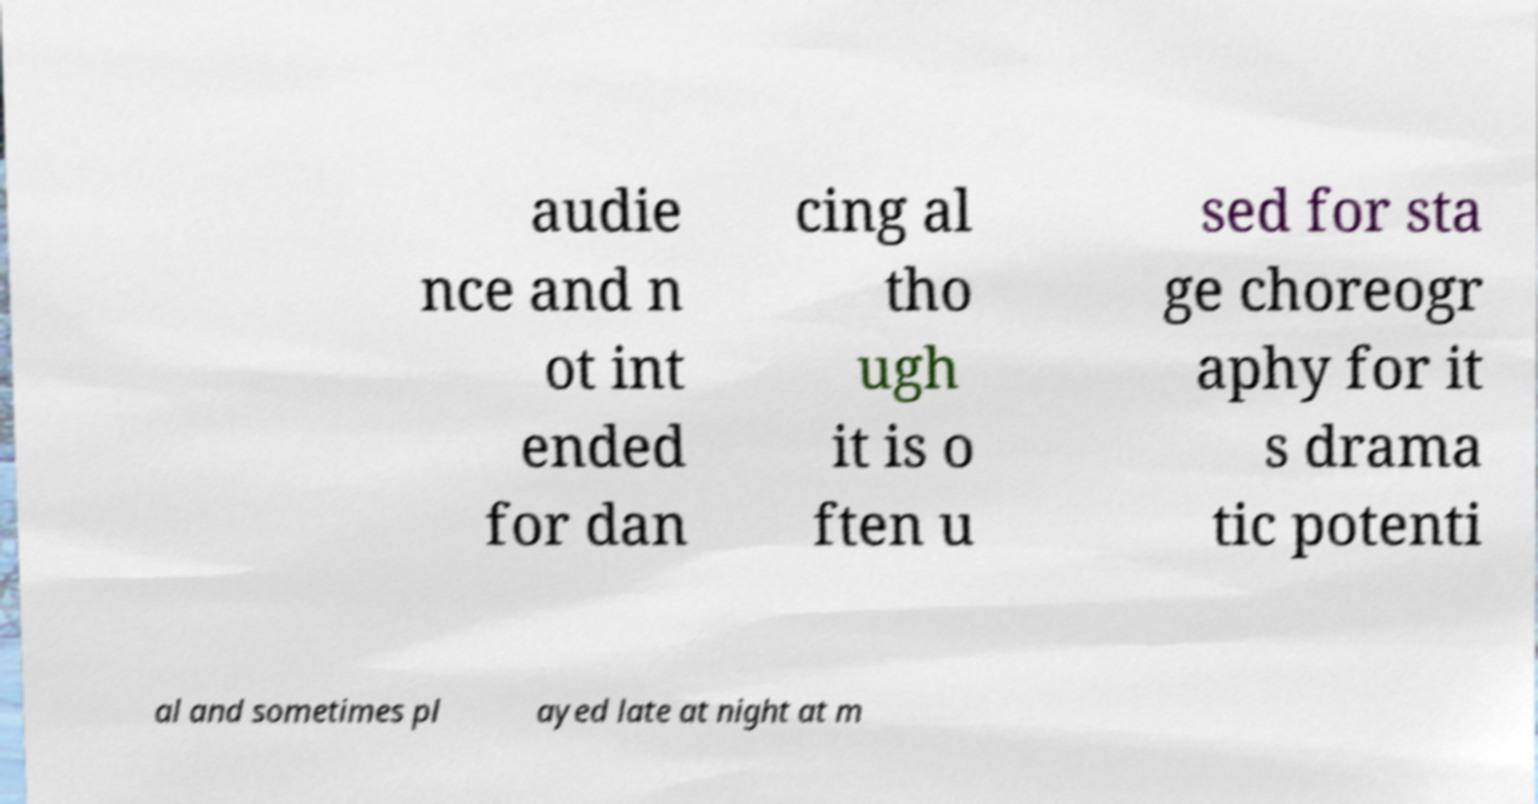Please identify and transcribe the text found in this image. audie nce and n ot int ended for dan cing al tho ugh it is o ften u sed for sta ge choreogr aphy for it s drama tic potenti al and sometimes pl ayed late at night at m 